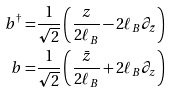<formula> <loc_0><loc_0><loc_500><loc_500>b ^ { \dagger } = & \frac { 1 } { \sqrt { 2 } } \left ( \frac { z } { 2 \ell _ { B } } - 2 \ell _ { B } \partial _ { \bar { z } } \right ) \\ b = & \frac { 1 } { \sqrt { 2 } } \left ( \frac { \bar { z } } { 2 \ell _ { B } } + 2 \ell _ { B } \partial _ { z } \right )</formula> 